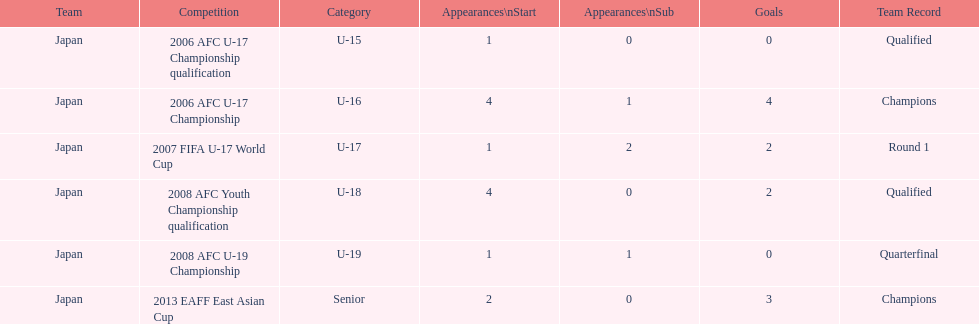Could you help me parse every detail presented in this table? {'header': ['Team', 'Competition', 'Category', 'Appearances\\nStart', 'Appearances\\nSub', 'Goals', 'Team Record'], 'rows': [['Japan', '2006 AFC U-17 Championship qualification', 'U-15', '1', '0', '0', 'Qualified'], ['Japan', '2006 AFC U-17 Championship', 'U-16', '4', '1', '4', 'Champions'], ['Japan', '2007 FIFA U-17 World Cup', 'U-17', '1', '2', '2', 'Round 1'], ['Japan', '2008 AFC Youth Championship qualification', 'U-18', '4', '0', '2', 'Qualified'], ['Japan', '2008 AFC U-19 Championship', 'U-19', '1', '1', '0', 'Quarterfinal'], ['Japan', '2013 EAFF East Asian Cup', 'Senior', '2', '0', '3', 'Champions']]} Was japan's number of starting appearances higher in the 2013 eaff east asian cup or the 2007 fifa u-17 world cup? 2013 EAFF East Asian Cup. 